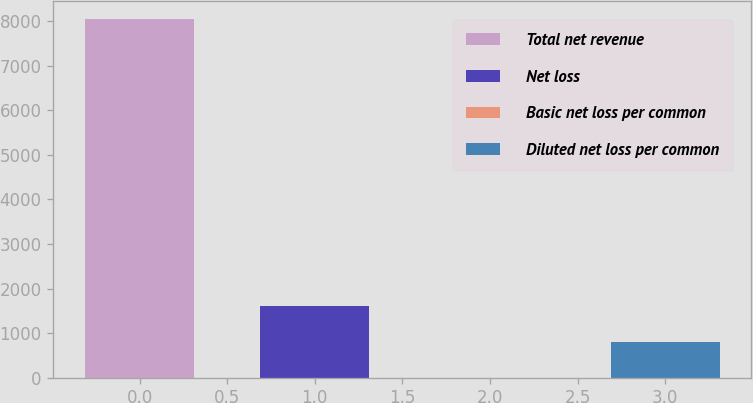Convert chart to OTSL. <chart><loc_0><loc_0><loc_500><loc_500><bar_chart><fcel>Total net revenue<fcel>Net loss<fcel>Basic net loss per common<fcel>Diluted net loss per common<nl><fcel>8047<fcel>1611.03<fcel>2.05<fcel>806.54<nl></chart> 